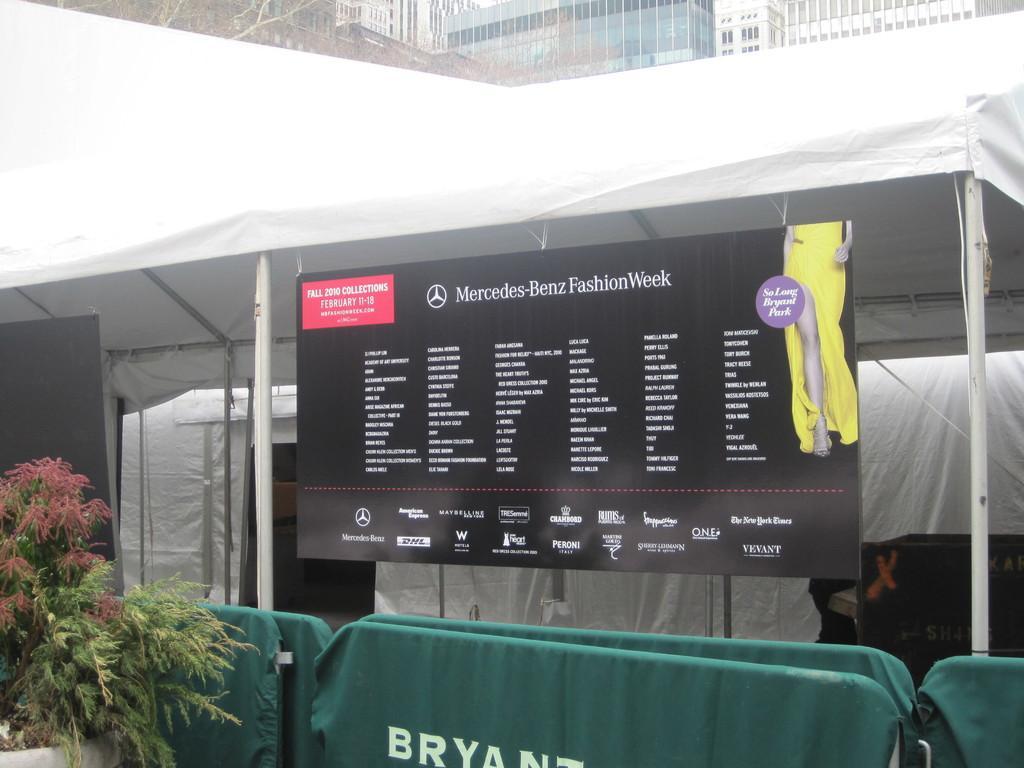Can you describe this image briefly? In this picture I can see the banner. I can see the tent. I can see the plants on the left side. I can see the buildings in the background. 